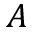Convert formula to latex. <formula><loc_0><loc_0><loc_500><loc_500>A</formula> 